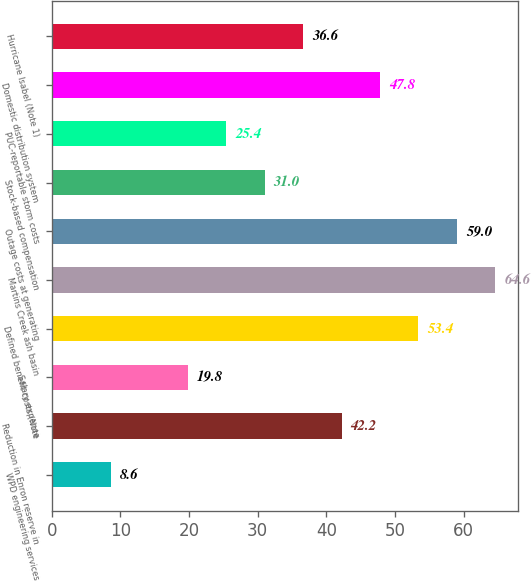Convert chart. <chart><loc_0><loc_0><loc_500><loc_500><bar_chart><fcel>WPD engineering services<fcel>Reduction in Enron reserve in<fcel>Salary expense<fcel>Defined benefit costs (Note<fcel>Martins Creek ash basin<fcel>Outage costs at generating<fcel>Stock-based compensation<fcel>PUC-reportable storm costs<fcel>Domestic distribution system<fcel>Hurricane Isabel (Note 1)<nl><fcel>8.6<fcel>42.2<fcel>19.8<fcel>53.4<fcel>64.6<fcel>59<fcel>31<fcel>25.4<fcel>47.8<fcel>36.6<nl></chart> 